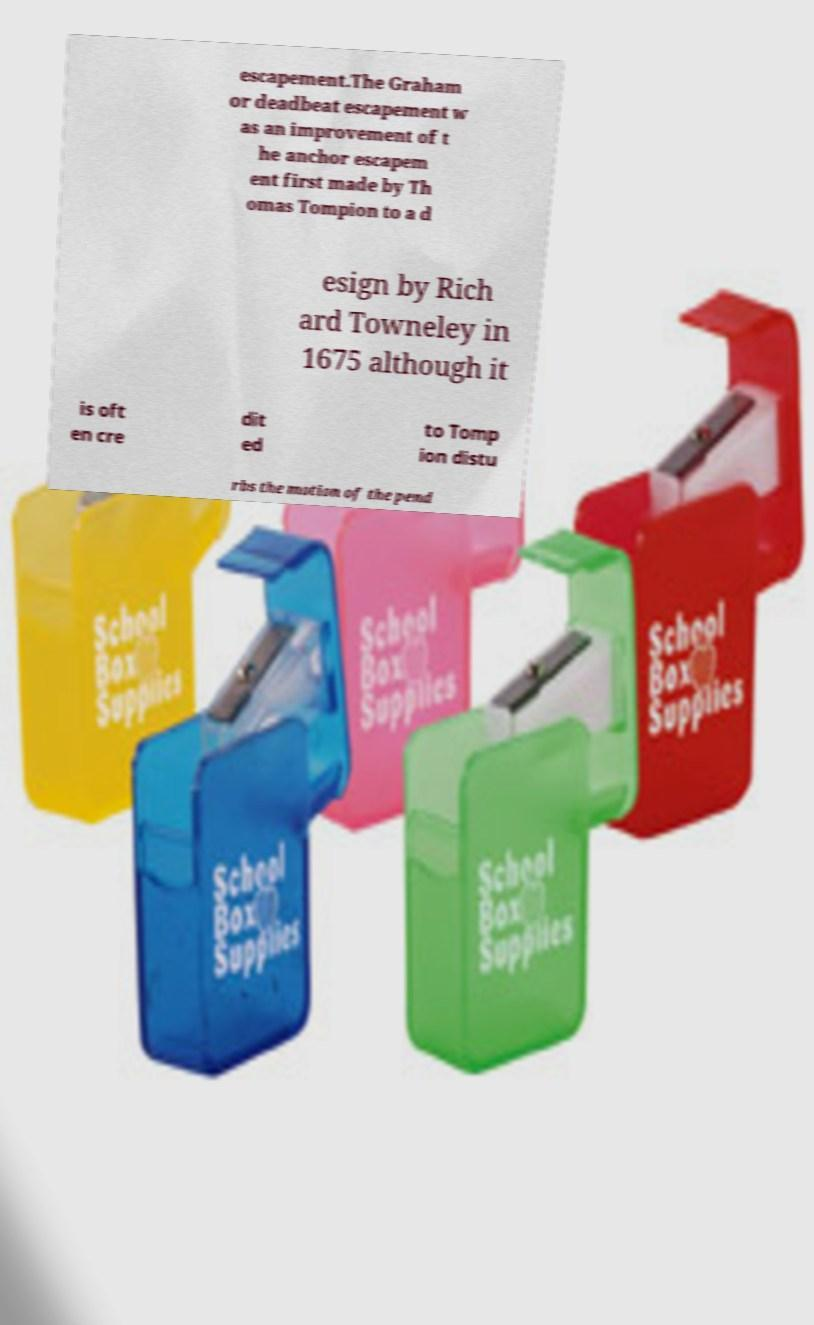I need the written content from this picture converted into text. Can you do that? escapement.The Graham or deadbeat escapement w as an improvement of t he anchor escapem ent first made by Th omas Tompion to a d esign by Rich ard Towneley in 1675 although it is oft en cre dit ed to Tomp ion distu rbs the motion of the pend 